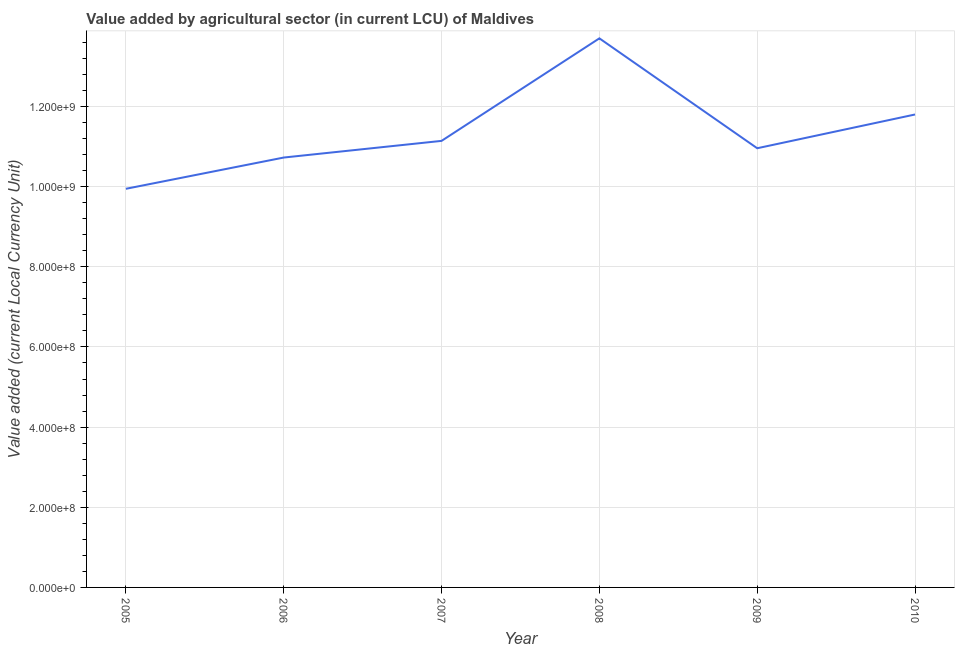What is the value added by agriculture sector in 2010?
Ensure brevity in your answer.  1.18e+09. Across all years, what is the maximum value added by agriculture sector?
Your response must be concise. 1.37e+09. Across all years, what is the minimum value added by agriculture sector?
Provide a succinct answer. 9.95e+08. In which year was the value added by agriculture sector maximum?
Offer a very short reply. 2008. In which year was the value added by agriculture sector minimum?
Make the answer very short. 2005. What is the sum of the value added by agriculture sector?
Provide a succinct answer. 6.83e+09. What is the difference between the value added by agriculture sector in 2006 and 2010?
Provide a short and direct response. -1.07e+08. What is the average value added by agriculture sector per year?
Provide a succinct answer. 1.14e+09. What is the median value added by agriculture sector?
Your response must be concise. 1.11e+09. In how many years, is the value added by agriculture sector greater than 1000000000 LCU?
Your answer should be compact. 5. What is the ratio of the value added by agriculture sector in 2005 to that in 2007?
Offer a terse response. 0.89. Is the value added by agriculture sector in 2006 less than that in 2009?
Keep it short and to the point. Yes. Is the difference between the value added by agriculture sector in 2007 and 2008 greater than the difference between any two years?
Your answer should be very brief. No. What is the difference between the highest and the second highest value added by agriculture sector?
Make the answer very short. 1.90e+08. What is the difference between the highest and the lowest value added by agriculture sector?
Your response must be concise. 3.75e+08. In how many years, is the value added by agriculture sector greater than the average value added by agriculture sector taken over all years?
Your answer should be very brief. 2. Does the value added by agriculture sector monotonically increase over the years?
Your answer should be very brief. No. What is the difference between two consecutive major ticks on the Y-axis?
Keep it short and to the point. 2.00e+08. Does the graph contain any zero values?
Provide a succinct answer. No. What is the title of the graph?
Your answer should be very brief. Value added by agricultural sector (in current LCU) of Maldives. What is the label or title of the Y-axis?
Provide a short and direct response. Value added (current Local Currency Unit). What is the Value added (current Local Currency Unit) of 2005?
Ensure brevity in your answer.  9.95e+08. What is the Value added (current Local Currency Unit) in 2006?
Provide a short and direct response. 1.07e+09. What is the Value added (current Local Currency Unit) of 2007?
Your answer should be very brief. 1.11e+09. What is the Value added (current Local Currency Unit) of 2008?
Provide a short and direct response. 1.37e+09. What is the Value added (current Local Currency Unit) of 2009?
Your answer should be very brief. 1.10e+09. What is the Value added (current Local Currency Unit) of 2010?
Offer a terse response. 1.18e+09. What is the difference between the Value added (current Local Currency Unit) in 2005 and 2006?
Provide a succinct answer. -7.80e+07. What is the difference between the Value added (current Local Currency Unit) in 2005 and 2007?
Provide a short and direct response. -1.20e+08. What is the difference between the Value added (current Local Currency Unit) in 2005 and 2008?
Your answer should be compact. -3.75e+08. What is the difference between the Value added (current Local Currency Unit) in 2005 and 2009?
Make the answer very short. -1.01e+08. What is the difference between the Value added (current Local Currency Unit) in 2005 and 2010?
Give a very brief answer. -1.85e+08. What is the difference between the Value added (current Local Currency Unit) in 2006 and 2007?
Your response must be concise. -4.16e+07. What is the difference between the Value added (current Local Currency Unit) in 2006 and 2008?
Ensure brevity in your answer.  -2.97e+08. What is the difference between the Value added (current Local Currency Unit) in 2006 and 2009?
Keep it short and to the point. -2.32e+07. What is the difference between the Value added (current Local Currency Unit) in 2006 and 2010?
Your answer should be compact. -1.07e+08. What is the difference between the Value added (current Local Currency Unit) in 2007 and 2008?
Ensure brevity in your answer.  -2.56e+08. What is the difference between the Value added (current Local Currency Unit) in 2007 and 2009?
Make the answer very short. 1.84e+07. What is the difference between the Value added (current Local Currency Unit) in 2007 and 2010?
Your response must be concise. -6.58e+07. What is the difference between the Value added (current Local Currency Unit) in 2008 and 2009?
Make the answer very short. 2.74e+08. What is the difference between the Value added (current Local Currency Unit) in 2008 and 2010?
Offer a very short reply. 1.90e+08. What is the difference between the Value added (current Local Currency Unit) in 2009 and 2010?
Offer a terse response. -8.42e+07. What is the ratio of the Value added (current Local Currency Unit) in 2005 to that in 2006?
Offer a very short reply. 0.93. What is the ratio of the Value added (current Local Currency Unit) in 2005 to that in 2007?
Offer a terse response. 0.89. What is the ratio of the Value added (current Local Currency Unit) in 2005 to that in 2008?
Your answer should be compact. 0.73. What is the ratio of the Value added (current Local Currency Unit) in 2005 to that in 2009?
Make the answer very short. 0.91. What is the ratio of the Value added (current Local Currency Unit) in 2005 to that in 2010?
Offer a very short reply. 0.84. What is the ratio of the Value added (current Local Currency Unit) in 2006 to that in 2008?
Ensure brevity in your answer.  0.78. What is the ratio of the Value added (current Local Currency Unit) in 2006 to that in 2009?
Your answer should be very brief. 0.98. What is the ratio of the Value added (current Local Currency Unit) in 2006 to that in 2010?
Make the answer very short. 0.91. What is the ratio of the Value added (current Local Currency Unit) in 2007 to that in 2008?
Your response must be concise. 0.81. What is the ratio of the Value added (current Local Currency Unit) in 2007 to that in 2009?
Give a very brief answer. 1.02. What is the ratio of the Value added (current Local Currency Unit) in 2007 to that in 2010?
Provide a short and direct response. 0.94. What is the ratio of the Value added (current Local Currency Unit) in 2008 to that in 2009?
Make the answer very short. 1.25. What is the ratio of the Value added (current Local Currency Unit) in 2008 to that in 2010?
Make the answer very short. 1.16. What is the ratio of the Value added (current Local Currency Unit) in 2009 to that in 2010?
Provide a short and direct response. 0.93. 